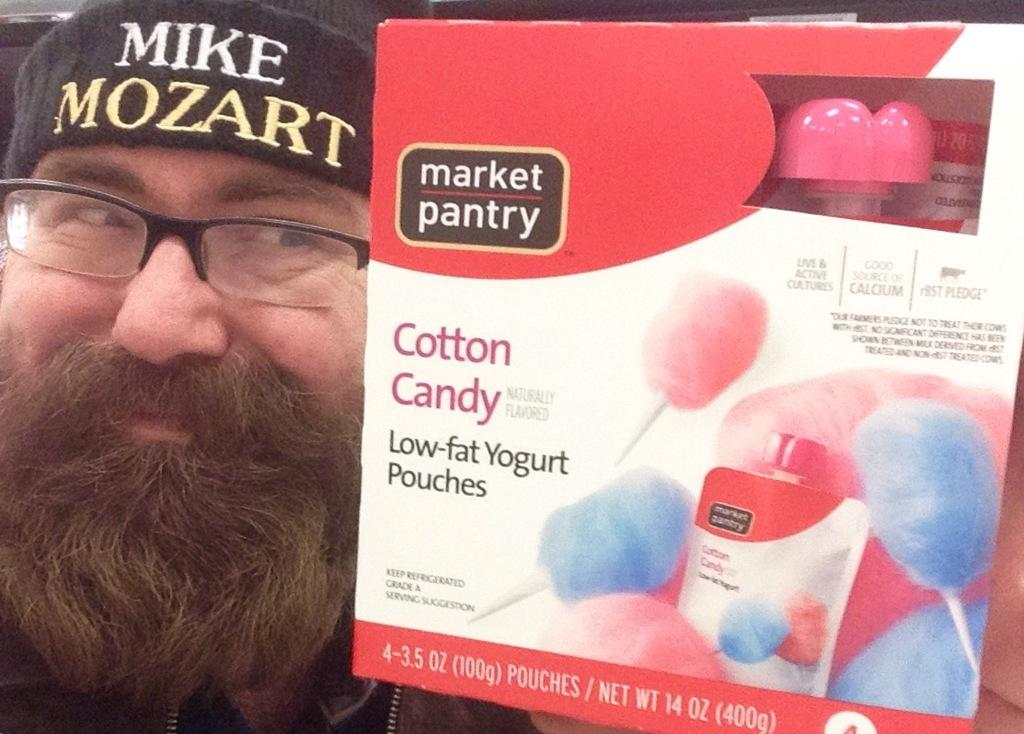What is the person in the image holding? The person is holding a box in the image. What can be seen on the box besides the person holding it? There is text and images on the box. What is the queen's opinion on the road in the image? There is no queen or road present in the image, so it is not possible to determine her opinion. 